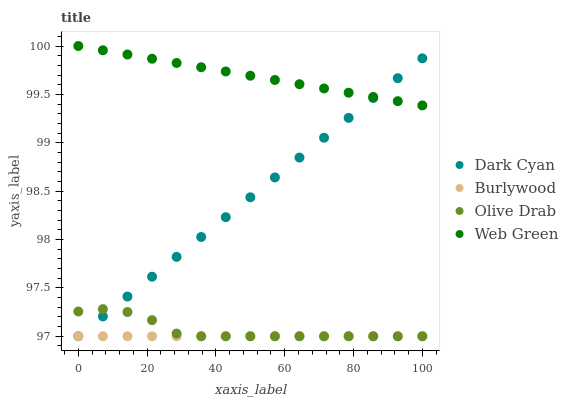Does Burlywood have the minimum area under the curve?
Answer yes or no. Yes. Does Web Green have the maximum area under the curve?
Answer yes or no. Yes. Does Web Green have the minimum area under the curve?
Answer yes or no. No. Does Burlywood have the maximum area under the curve?
Answer yes or no. No. Is Burlywood the smoothest?
Answer yes or no. Yes. Is Olive Drab the roughest?
Answer yes or no. Yes. Is Web Green the smoothest?
Answer yes or no. No. Is Web Green the roughest?
Answer yes or no. No. Does Dark Cyan have the lowest value?
Answer yes or no. Yes. Does Web Green have the lowest value?
Answer yes or no. No. Does Web Green have the highest value?
Answer yes or no. Yes. Does Burlywood have the highest value?
Answer yes or no. No. Is Olive Drab less than Web Green?
Answer yes or no. Yes. Is Web Green greater than Burlywood?
Answer yes or no. Yes. Does Olive Drab intersect Burlywood?
Answer yes or no. Yes. Is Olive Drab less than Burlywood?
Answer yes or no. No. Is Olive Drab greater than Burlywood?
Answer yes or no. No. Does Olive Drab intersect Web Green?
Answer yes or no. No. 